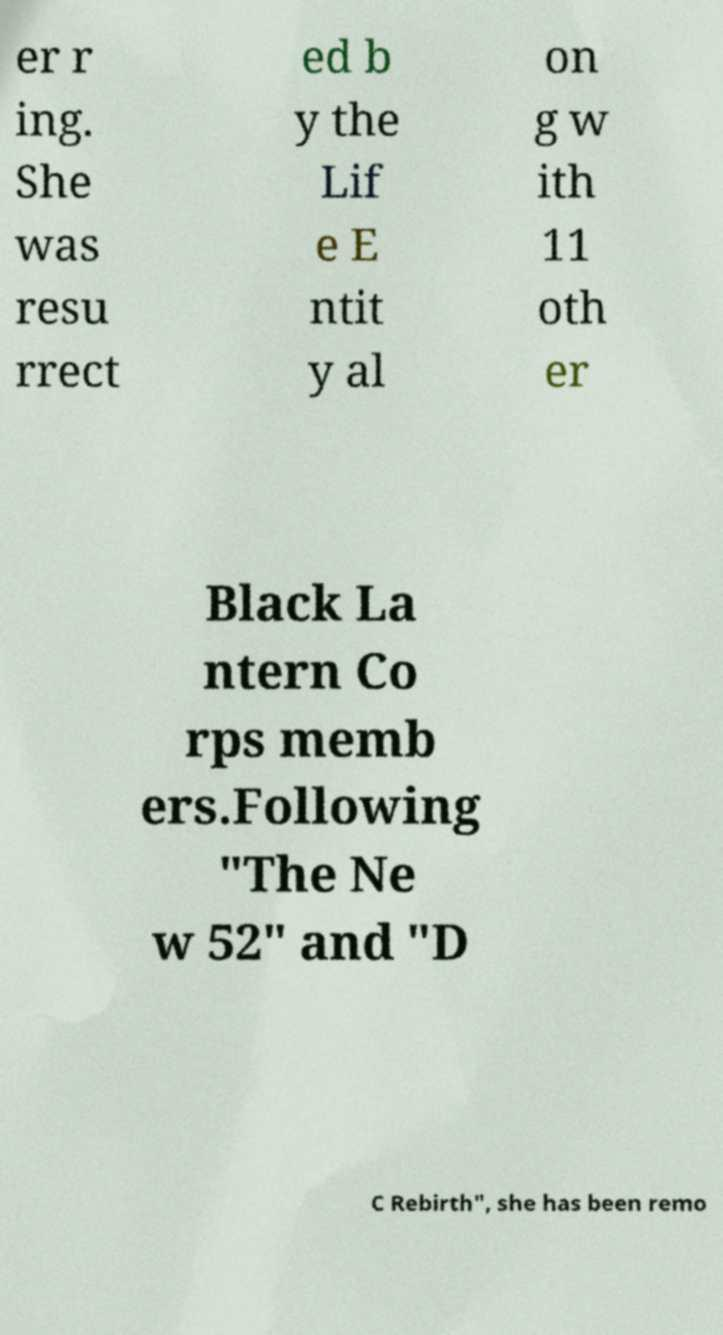Can you accurately transcribe the text from the provided image for me? er r ing. She was resu rrect ed b y the Lif e E ntit y al on g w ith 11 oth er Black La ntern Co rps memb ers.Following "The Ne w 52" and "D C Rebirth", she has been remo 